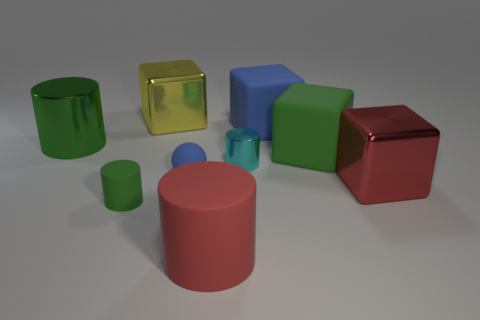Subtract all large red cubes. How many cubes are left? 3 Add 1 tiny purple things. How many objects exist? 10 Subtract all red cylinders. How many cylinders are left? 3 Subtract all balls. How many objects are left? 8 Subtract 2 blocks. How many blocks are left? 2 Subtract all brown cylinders. Subtract all purple balls. How many cylinders are left? 4 Subtract all green cubes. How many red cylinders are left? 1 Subtract all small blue objects. Subtract all large green cubes. How many objects are left? 7 Add 5 small rubber cylinders. How many small rubber cylinders are left? 6 Add 9 red blocks. How many red blocks exist? 10 